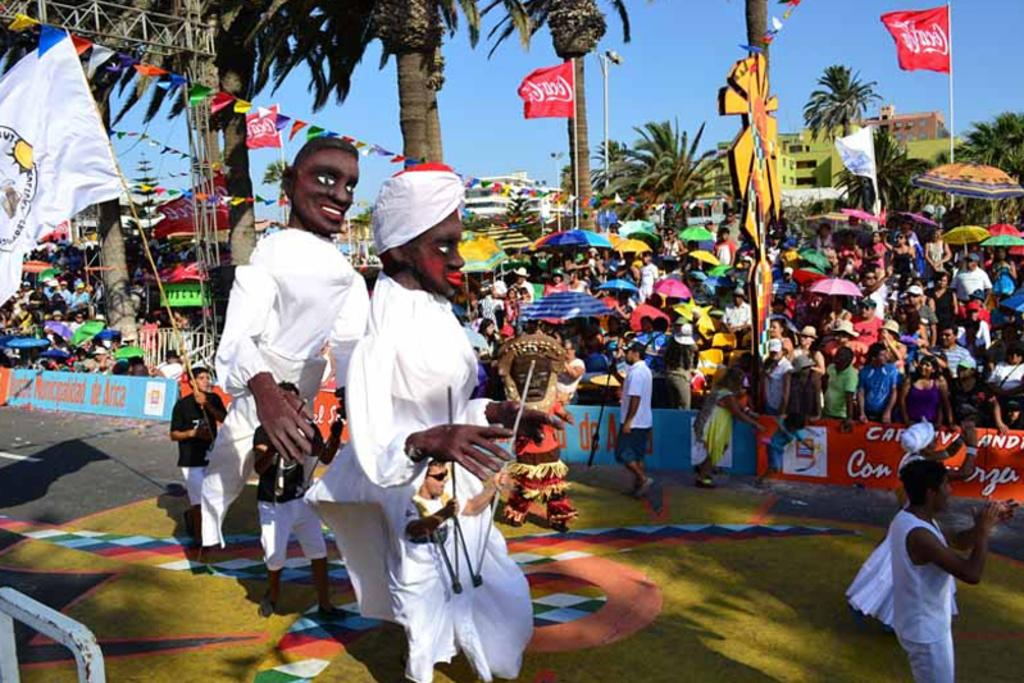Provide a one-sentence caption for the provided image. Coca Cola banners are being flown at a festival in a tropical location. 